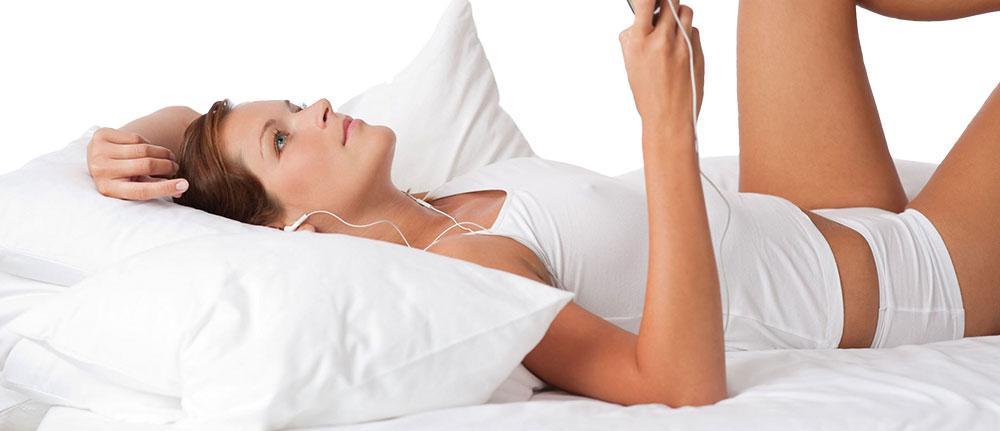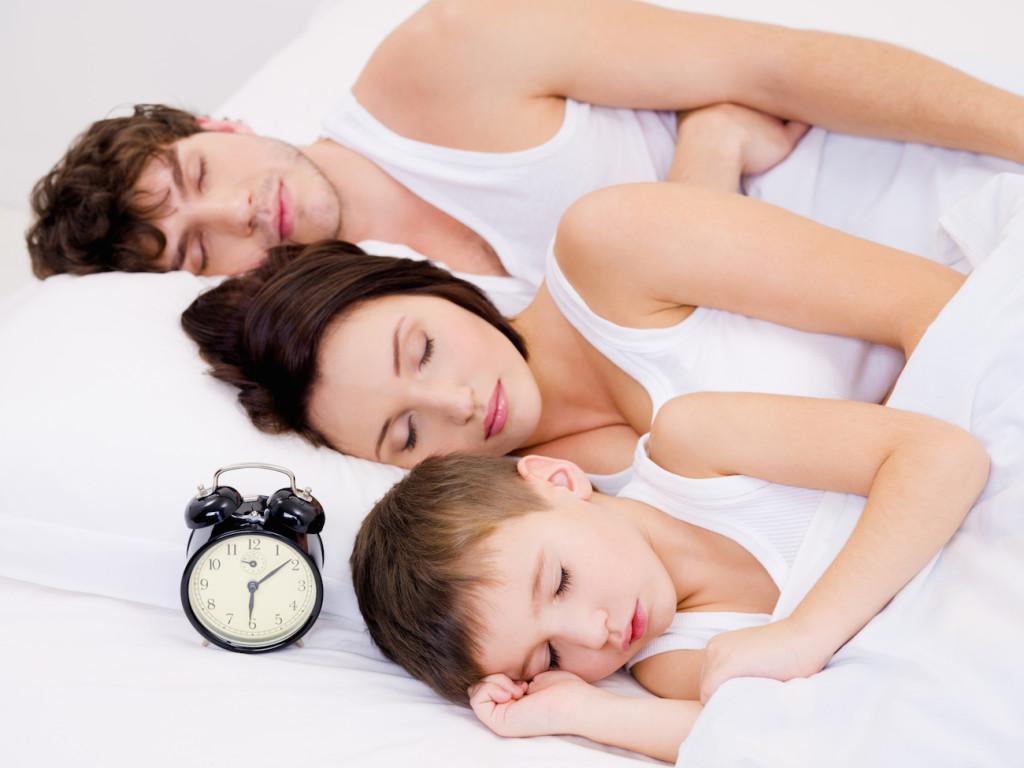The first image is the image on the left, the second image is the image on the right. For the images shown, is this caption "A single person is sleeping on a pillow in each of the images." true? Answer yes or no. No. 